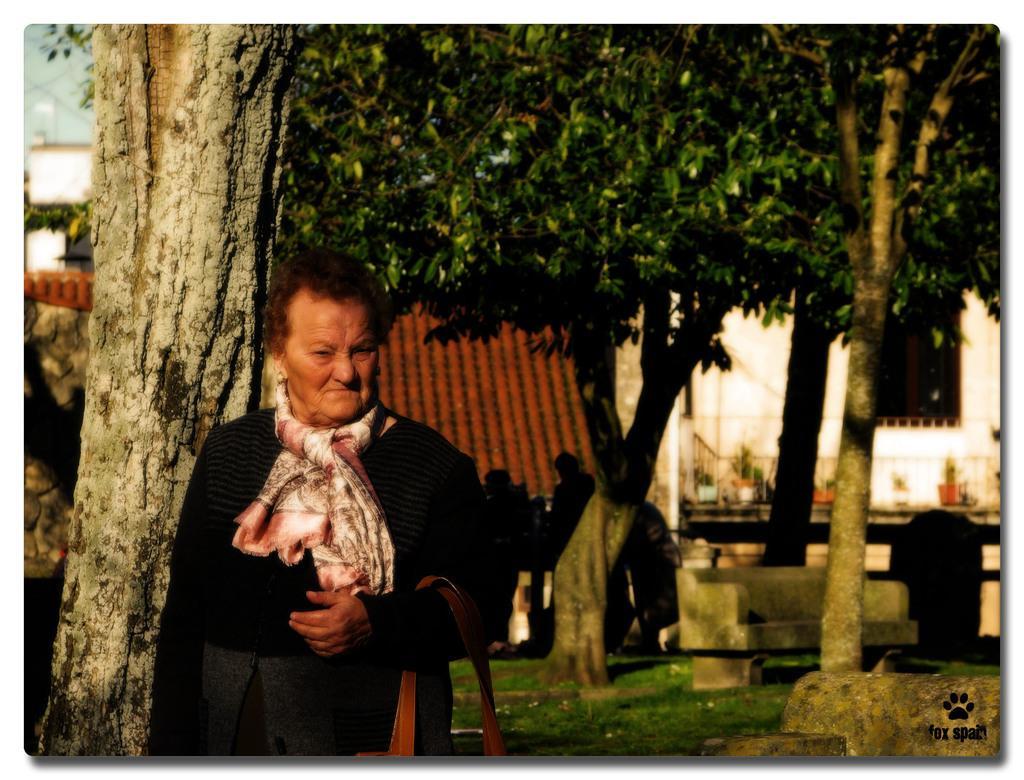In one or two sentences, can you explain what this image depicts? In the image there is a lady with stole and bag in her hand. Behind her there are trees and also there are benches. There are few people. And also there is a building with walls and a roof in the background. In the bottom right corner of the image there is a logo. And on the ground there is grass. 